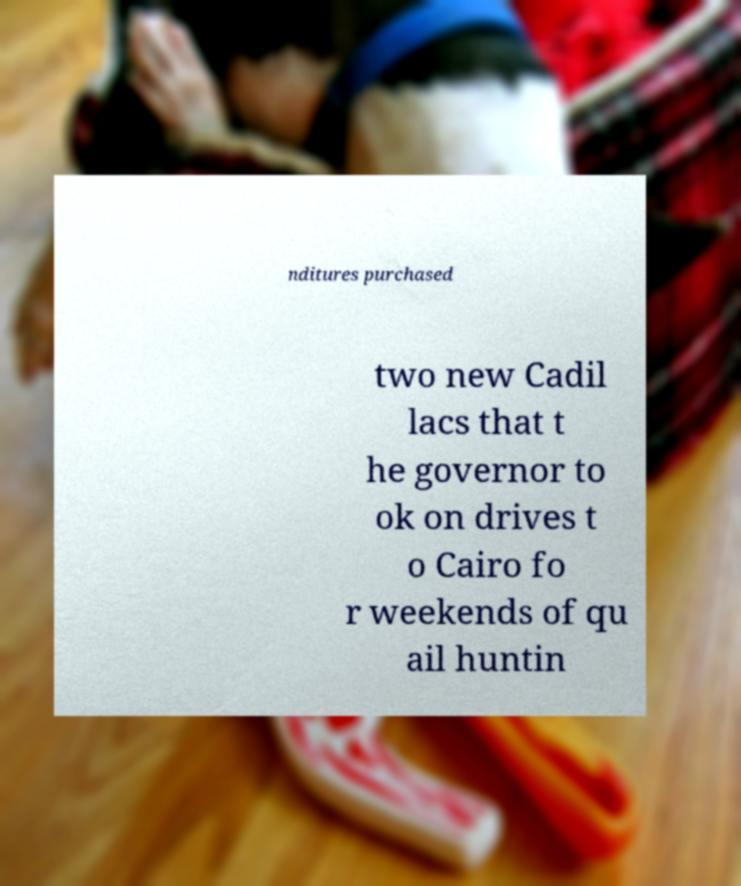Can you accurately transcribe the text from the provided image for me? nditures purchased two new Cadil lacs that t he governor to ok on drives t o Cairo fo r weekends of qu ail huntin 